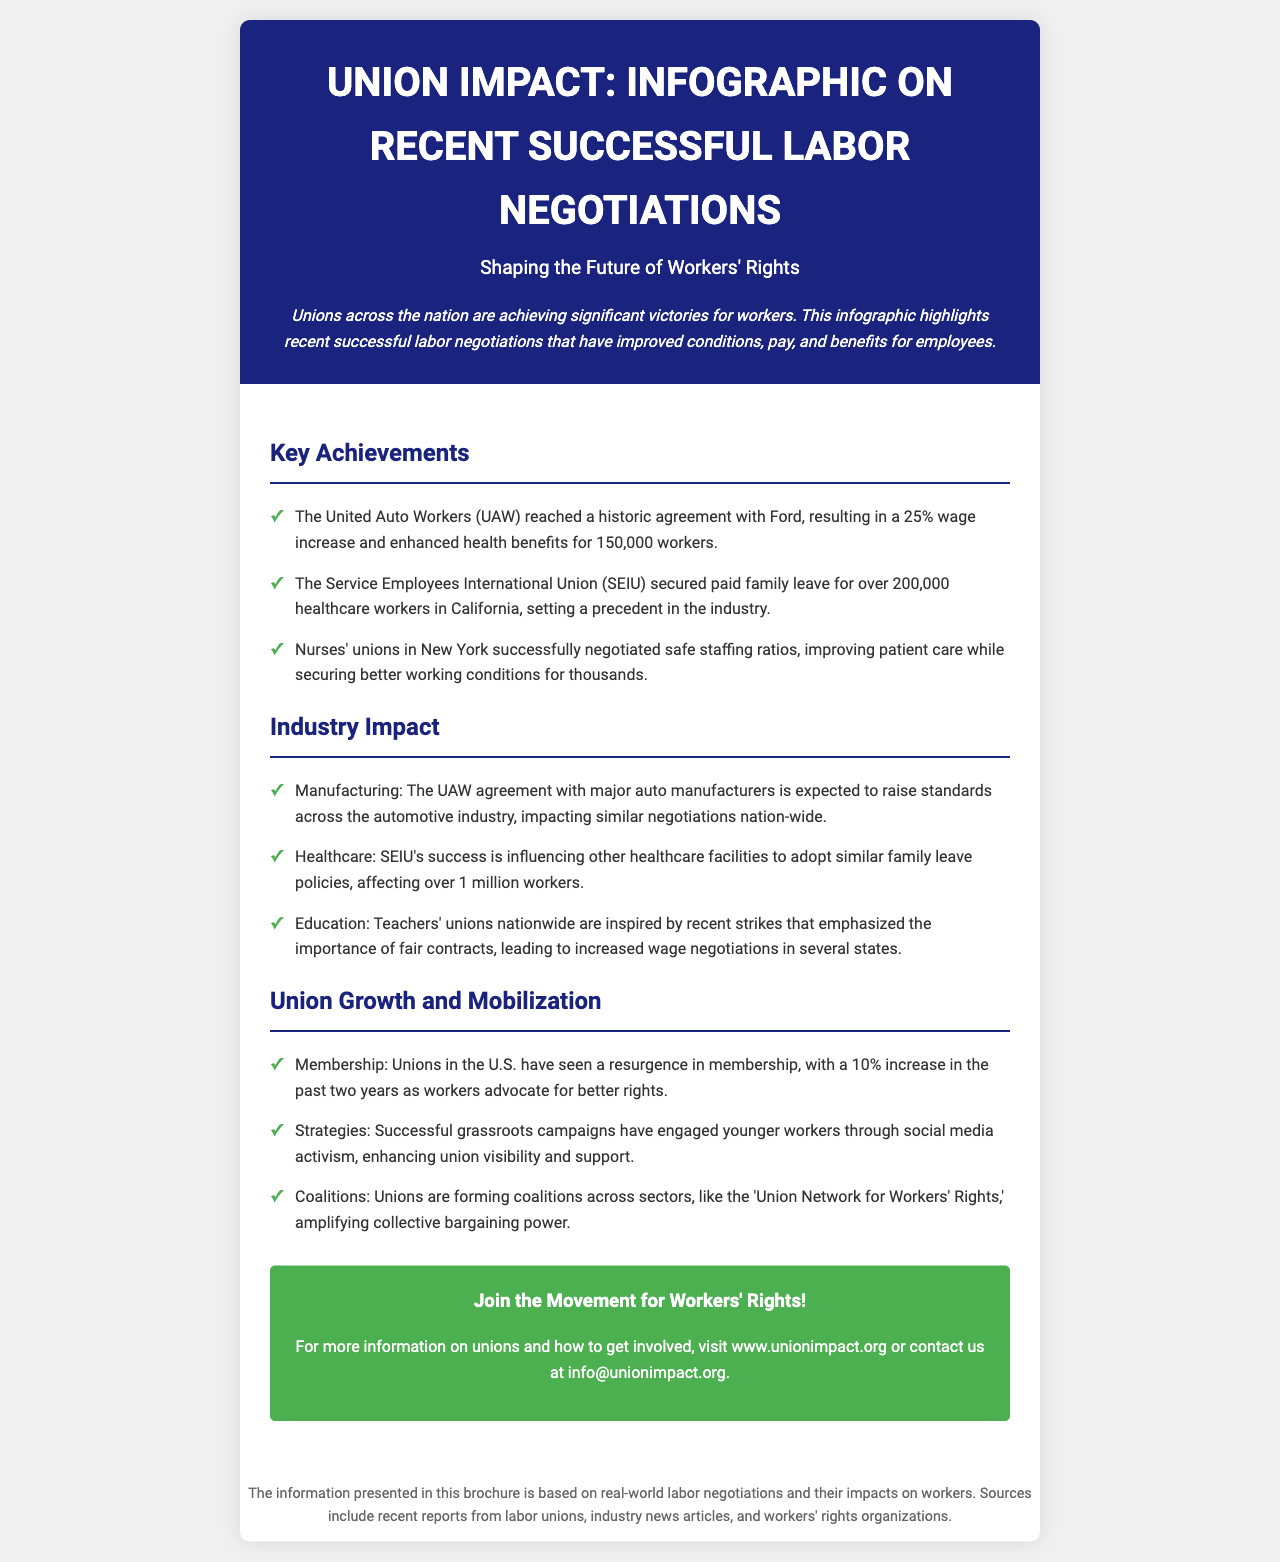What is the wage increase achieved by the UAW with Ford? The document states that the UAW reached a historic agreement with Ford resulting in a 25% wage increase.
Answer: 25% How many healthcare workers in California secured paid family leave through SEIU? According to the document, SEIU secured paid family leave for over 200,000 healthcare workers in California.
Answer: 200,000 What is one impact of the UAW agreement on the manufacturing industry? The document mentions that the UAW agreement with major auto manufacturers is expected to raise standards across the automotive industry.
Answer: Raise standards What percentage increase in union membership has been observed in the past two years? The document states that unions in the U.S. have seen a 10% increase in membership over the past two years.
Answer: 10% What is the purpose of the 'Union Network for Workers' Rights'? The document states that the coalition amplifies collective bargaining power among unions.
Answer: Amplify collective bargaining power Which union negotiated safe staffing ratios for nurses? The document notes that nurses' unions in New York successfully negotiated safe staffing ratios.
Answer: Nurses' unions What kind of activism has engaged younger workers according to the brochure? The document mentions that successful grassroots campaigns engaged younger workers through social media activism.
Answer: Social media activism What major industry is influenced by SEIU's success in family leave policies? The document notes that SEIU's success influences other healthcare facilities.
Answer: Healthcare 